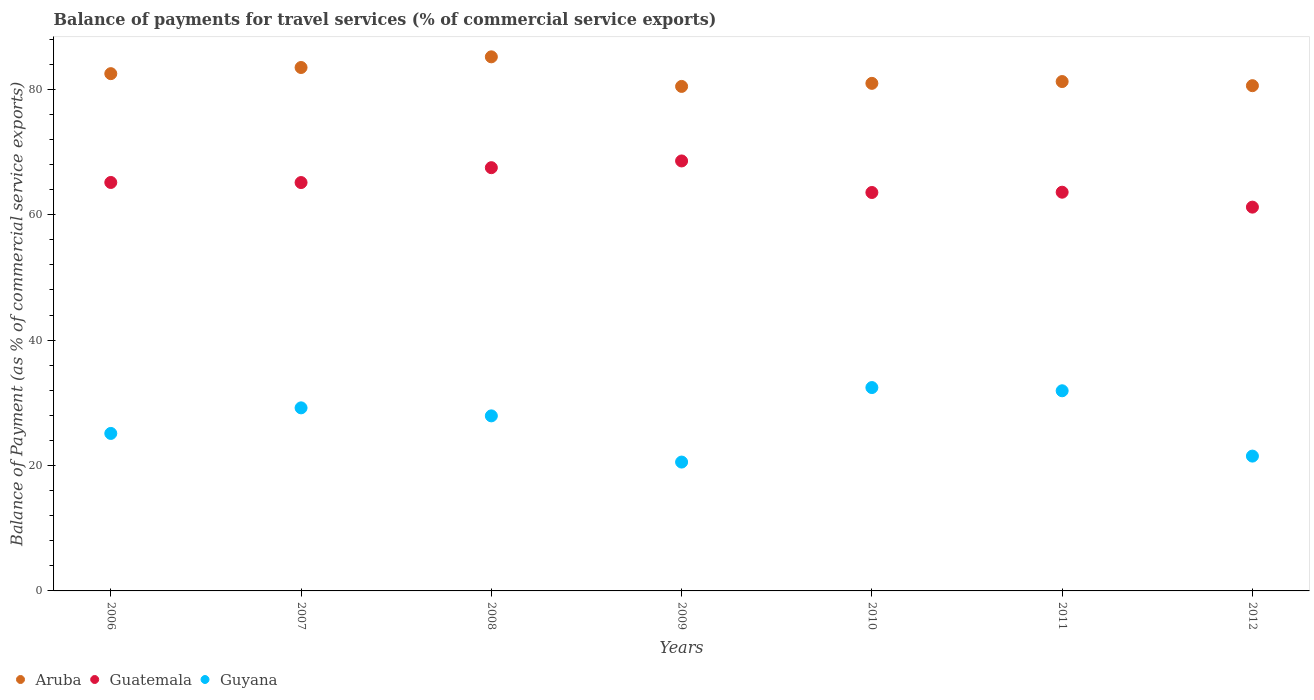Is the number of dotlines equal to the number of legend labels?
Provide a succinct answer. Yes. What is the balance of payments for travel services in Aruba in 2006?
Your answer should be very brief. 82.5. Across all years, what is the maximum balance of payments for travel services in Aruba?
Offer a very short reply. 85.18. Across all years, what is the minimum balance of payments for travel services in Aruba?
Ensure brevity in your answer.  80.47. What is the total balance of payments for travel services in Guatemala in the graph?
Your answer should be very brief. 454.72. What is the difference between the balance of payments for travel services in Guyana in 2006 and that in 2012?
Your response must be concise. 3.62. What is the difference between the balance of payments for travel services in Guatemala in 2011 and the balance of payments for travel services in Guyana in 2009?
Provide a succinct answer. 43.04. What is the average balance of payments for travel services in Aruba per year?
Your answer should be compact. 82.06. In the year 2008, what is the difference between the balance of payments for travel services in Guyana and balance of payments for travel services in Aruba?
Your answer should be very brief. -57.26. What is the ratio of the balance of payments for travel services in Guatemala in 2008 to that in 2010?
Your answer should be very brief. 1.06. Is the difference between the balance of payments for travel services in Guyana in 2007 and 2012 greater than the difference between the balance of payments for travel services in Aruba in 2007 and 2012?
Give a very brief answer. Yes. What is the difference between the highest and the second highest balance of payments for travel services in Guyana?
Make the answer very short. 0.51. What is the difference between the highest and the lowest balance of payments for travel services in Aruba?
Your answer should be very brief. 4.72. In how many years, is the balance of payments for travel services in Aruba greater than the average balance of payments for travel services in Aruba taken over all years?
Ensure brevity in your answer.  3. Is the sum of the balance of payments for travel services in Guatemala in 2010 and 2012 greater than the maximum balance of payments for travel services in Aruba across all years?
Your response must be concise. Yes. Is it the case that in every year, the sum of the balance of payments for travel services in Aruba and balance of payments for travel services in Guyana  is greater than the balance of payments for travel services in Guatemala?
Offer a very short reply. Yes. What is the difference between two consecutive major ticks on the Y-axis?
Your answer should be very brief. 20. Does the graph contain any zero values?
Keep it short and to the point. No. How many legend labels are there?
Your response must be concise. 3. How are the legend labels stacked?
Keep it short and to the point. Horizontal. What is the title of the graph?
Offer a very short reply. Balance of payments for travel services (% of commercial service exports). Does "Burkina Faso" appear as one of the legend labels in the graph?
Provide a short and direct response. No. What is the label or title of the Y-axis?
Offer a terse response. Balance of Payment (as % of commercial service exports). What is the Balance of Payment (as % of commercial service exports) of Aruba in 2006?
Offer a very short reply. 82.5. What is the Balance of Payment (as % of commercial service exports) of Guatemala in 2006?
Offer a terse response. 65.15. What is the Balance of Payment (as % of commercial service exports) in Guyana in 2006?
Your answer should be very brief. 25.12. What is the Balance of Payment (as % of commercial service exports) in Aruba in 2007?
Make the answer very short. 83.48. What is the Balance of Payment (as % of commercial service exports) in Guatemala in 2007?
Your response must be concise. 65.13. What is the Balance of Payment (as % of commercial service exports) in Guyana in 2007?
Offer a very short reply. 29.2. What is the Balance of Payment (as % of commercial service exports) of Aruba in 2008?
Ensure brevity in your answer.  85.18. What is the Balance of Payment (as % of commercial service exports) of Guatemala in 2008?
Your answer should be very brief. 67.51. What is the Balance of Payment (as % of commercial service exports) of Guyana in 2008?
Give a very brief answer. 27.92. What is the Balance of Payment (as % of commercial service exports) of Aruba in 2009?
Your answer should be compact. 80.47. What is the Balance of Payment (as % of commercial service exports) in Guatemala in 2009?
Provide a succinct answer. 68.58. What is the Balance of Payment (as % of commercial service exports) of Guyana in 2009?
Provide a succinct answer. 20.55. What is the Balance of Payment (as % of commercial service exports) of Aruba in 2010?
Offer a terse response. 80.95. What is the Balance of Payment (as % of commercial service exports) of Guatemala in 2010?
Provide a succinct answer. 63.55. What is the Balance of Payment (as % of commercial service exports) of Guyana in 2010?
Your answer should be very brief. 32.44. What is the Balance of Payment (as % of commercial service exports) of Aruba in 2011?
Your answer should be very brief. 81.24. What is the Balance of Payment (as % of commercial service exports) of Guatemala in 2011?
Provide a short and direct response. 63.59. What is the Balance of Payment (as % of commercial service exports) of Guyana in 2011?
Offer a terse response. 31.92. What is the Balance of Payment (as % of commercial service exports) of Aruba in 2012?
Keep it short and to the point. 80.58. What is the Balance of Payment (as % of commercial service exports) in Guatemala in 2012?
Provide a succinct answer. 61.21. What is the Balance of Payment (as % of commercial service exports) in Guyana in 2012?
Your answer should be very brief. 21.5. Across all years, what is the maximum Balance of Payment (as % of commercial service exports) of Aruba?
Offer a very short reply. 85.18. Across all years, what is the maximum Balance of Payment (as % of commercial service exports) of Guatemala?
Provide a succinct answer. 68.58. Across all years, what is the maximum Balance of Payment (as % of commercial service exports) of Guyana?
Your response must be concise. 32.44. Across all years, what is the minimum Balance of Payment (as % of commercial service exports) in Aruba?
Ensure brevity in your answer.  80.47. Across all years, what is the minimum Balance of Payment (as % of commercial service exports) in Guatemala?
Offer a terse response. 61.21. Across all years, what is the minimum Balance of Payment (as % of commercial service exports) of Guyana?
Offer a very short reply. 20.55. What is the total Balance of Payment (as % of commercial service exports) of Aruba in the graph?
Provide a short and direct response. 574.42. What is the total Balance of Payment (as % of commercial service exports) of Guatemala in the graph?
Provide a short and direct response. 454.72. What is the total Balance of Payment (as % of commercial service exports) of Guyana in the graph?
Give a very brief answer. 188.65. What is the difference between the Balance of Payment (as % of commercial service exports) of Aruba in 2006 and that in 2007?
Offer a very short reply. -0.98. What is the difference between the Balance of Payment (as % of commercial service exports) in Guatemala in 2006 and that in 2007?
Your answer should be compact. 0.01. What is the difference between the Balance of Payment (as % of commercial service exports) of Guyana in 2006 and that in 2007?
Your response must be concise. -4.08. What is the difference between the Balance of Payment (as % of commercial service exports) in Aruba in 2006 and that in 2008?
Your response must be concise. -2.68. What is the difference between the Balance of Payment (as % of commercial service exports) in Guatemala in 2006 and that in 2008?
Provide a short and direct response. -2.36. What is the difference between the Balance of Payment (as % of commercial service exports) in Guyana in 2006 and that in 2008?
Make the answer very short. -2.8. What is the difference between the Balance of Payment (as % of commercial service exports) of Aruba in 2006 and that in 2009?
Make the answer very short. 2.04. What is the difference between the Balance of Payment (as % of commercial service exports) of Guatemala in 2006 and that in 2009?
Your answer should be compact. -3.43. What is the difference between the Balance of Payment (as % of commercial service exports) of Guyana in 2006 and that in 2009?
Keep it short and to the point. 4.57. What is the difference between the Balance of Payment (as % of commercial service exports) in Aruba in 2006 and that in 2010?
Offer a terse response. 1.55. What is the difference between the Balance of Payment (as % of commercial service exports) in Guatemala in 2006 and that in 2010?
Give a very brief answer. 1.6. What is the difference between the Balance of Payment (as % of commercial service exports) in Guyana in 2006 and that in 2010?
Provide a succinct answer. -7.32. What is the difference between the Balance of Payment (as % of commercial service exports) in Aruba in 2006 and that in 2011?
Provide a succinct answer. 1.26. What is the difference between the Balance of Payment (as % of commercial service exports) in Guatemala in 2006 and that in 2011?
Provide a succinct answer. 1.55. What is the difference between the Balance of Payment (as % of commercial service exports) of Guyana in 2006 and that in 2011?
Provide a succinct answer. -6.8. What is the difference between the Balance of Payment (as % of commercial service exports) in Aruba in 2006 and that in 2012?
Offer a very short reply. 1.92. What is the difference between the Balance of Payment (as % of commercial service exports) of Guatemala in 2006 and that in 2012?
Give a very brief answer. 3.93. What is the difference between the Balance of Payment (as % of commercial service exports) in Guyana in 2006 and that in 2012?
Offer a terse response. 3.62. What is the difference between the Balance of Payment (as % of commercial service exports) in Aruba in 2007 and that in 2008?
Ensure brevity in your answer.  -1.7. What is the difference between the Balance of Payment (as % of commercial service exports) of Guatemala in 2007 and that in 2008?
Make the answer very short. -2.37. What is the difference between the Balance of Payment (as % of commercial service exports) of Guyana in 2007 and that in 2008?
Make the answer very short. 1.28. What is the difference between the Balance of Payment (as % of commercial service exports) in Aruba in 2007 and that in 2009?
Your answer should be compact. 3.02. What is the difference between the Balance of Payment (as % of commercial service exports) of Guatemala in 2007 and that in 2009?
Your answer should be very brief. -3.45. What is the difference between the Balance of Payment (as % of commercial service exports) in Guyana in 2007 and that in 2009?
Offer a very short reply. 8.65. What is the difference between the Balance of Payment (as % of commercial service exports) of Aruba in 2007 and that in 2010?
Give a very brief answer. 2.53. What is the difference between the Balance of Payment (as % of commercial service exports) of Guatemala in 2007 and that in 2010?
Your answer should be very brief. 1.59. What is the difference between the Balance of Payment (as % of commercial service exports) in Guyana in 2007 and that in 2010?
Offer a very short reply. -3.24. What is the difference between the Balance of Payment (as % of commercial service exports) in Aruba in 2007 and that in 2011?
Make the answer very short. 2.24. What is the difference between the Balance of Payment (as % of commercial service exports) of Guatemala in 2007 and that in 2011?
Make the answer very short. 1.54. What is the difference between the Balance of Payment (as % of commercial service exports) of Guyana in 2007 and that in 2011?
Offer a terse response. -2.72. What is the difference between the Balance of Payment (as % of commercial service exports) in Aruba in 2007 and that in 2012?
Provide a succinct answer. 2.9. What is the difference between the Balance of Payment (as % of commercial service exports) of Guatemala in 2007 and that in 2012?
Provide a succinct answer. 3.92. What is the difference between the Balance of Payment (as % of commercial service exports) in Guyana in 2007 and that in 2012?
Provide a short and direct response. 7.7. What is the difference between the Balance of Payment (as % of commercial service exports) of Aruba in 2008 and that in 2009?
Offer a very short reply. 4.72. What is the difference between the Balance of Payment (as % of commercial service exports) in Guatemala in 2008 and that in 2009?
Make the answer very short. -1.07. What is the difference between the Balance of Payment (as % of commercial service exports) in Guyana in 2008 and that in 2009?
Make the answer very short. 7.37. What is the difference between the Balance of Payment (as % of commercial service exports) in Aruba in 2008 and that in 2010?
Your answer should be very brief. 4.23. What is the difference between the Balance of Payment (as % of commercial service exports) of Guatemala in 2008 and that in 2010?
Provide a short and direct response. 3.96. What is the difference between the Balance of Payment (as % of commercial service exports) of Guyana in 2008 and that in 2010?
Your answer should be compact. -4.52. What is the difference between the Balance of Payment (as % of commercial service exports) of Aruba in 2008 and that in 2011?
Ensure brevity in your answer.  3.94. What is the difference between the Balance of Payment (as % of commercial service exports) of Guatemala in 2008 and that in 2011?
Offer a terse response. 3.91. What is the difference between the Balance of Payment (as % of commercial service exports) in Guyana in 2008 and that in 2011?
Provide a succinct answer. -4. What is the difference between the Balance of Payment (as % of commercial service exports) of Aruba in 2008 and that in 2012?
Keep it short and to the point. 4.6. What is the difference between the Balance of Payment (as % of commercial service exports) in Guatemala in 2008 and that in 2012?
Offer a terse response. 6.29. What is the difference between the Balance of Payment (as % of commercial service exports) of Guyana in 2008 and that in 2012?
Offer a very short reply. 6.42. What is the difference between the Balance of Payment (as % of commercial service exports) in Aruba in 2009 and that in 2010?
Keep it short and to the point. -0.49. What is the difference between the Balance of Payment (as % of commercial service exports) of Guatemala in 2009 and that in 2010?
Offer a terse response. 5.03. What is the difference between the Balance of Payment (as % of commercial service exports) in Guyana in 2009 and that in 2010?
Keep it short and to the point. -11.88. What is the difference between the Balance of Payment (as % of commercial service exports) of Aruba in 2009 and that in 2011?
Make the answer very short. -0.78. What is the difference between the Balance of Payment (as % of commercial service exports) of Guatemala in 2009 and that in 2011?
Your answer should be very brief. 4.99. What is the difference between the Balance of Payment (as % of commercial service exports) of Guyana in 2009 and that in 2011?
Ensure brevity in your answer.  -11.37. What is the difference between the Balance of Payment (as % of commercial service exports) of Aruba in 2009 and that in 2012?
Your answer should be very brief. -0.12. What is the difference between the Balance of Payment (as % of commercial service exports) in Guatemala in 2009 and that in 2012?
Provide a succinct answer. 7.37. What is the difference between the Balance of Payment (as % of commercial service exports) in Guyana in 2009 and that in 2012?
Your answer should be very brief. -0.95. What is the difference between the Balance of Payment (as % of commercial service exports) in Aruba in 2010 and that in 2011?
Ensure brevity in your answer.  -0.29. What is the difference between the Balance of Payment (as % of commercial service exports) of Guatemala in 2010 and that in 2011?
Provide a short and direct response. -0.05. What is the difference between the Balance of Payment (as % of commercial service exports) in Guyana in 2010 and that in 2011?
Offer a terse response. 0.51. What is the difference between the Balance of Payment (as % of commercial service exports) of Aruba in 2010 and that in 2012?
Make the answer very short. 0.37. What is the difference between the Balance of Payment (as % of commercial service exports) in Guatemala in 2010 and that in 2012?
Provide a succinct answer. 2.33. What is the difference between the Balance of Payment (as % of commercial service exports) of Guyana in 2010 and that in 2012?
Provide a succinct answer. 10.93. What is the difference between the Balance of Payment (as % of commercial service exports) in Aruba in 2011 and that in 2012?
Your answer should be very brief. 0.66. What is the difference between the Balance of Payment (as % of commercial service exports) of Guatemala in 2011 and that in 2012?
Keep it short and to the point. 2.38. What is the difference between the Balance of Payment (as % of commercial service exports) of Guyana in 2011 and that in 2012?
Give a very brief answer. 10.42. What is the difference between the Balance of Payment (as % of commercial service exports) in Aruba in 2006 and the Balance of Payment (as % of commercial service exports) in Guatemala in 2007?
Offer a terse response. 17.37. What is the difference between the Balance of Payment (as % of commercial service exports) in Aruba in 2006 and the Balance of Payment (as % of commercial service exports) in Guyana in 2007?
Keep it short and to the point. 53.3. What is the difference between the Balance of Payment (as % of commercial service exports) of Guatemala in 2006 and the Balance of Payment (as % of commercial service exports) of Guyana in 2007?
Provide a succinct answer. 35.95. What is the difference between the Balance of Payment (as % of commercial service exports) of Aruba in 2006 and the Balance of Payment (as % of commercial service exports) of Guatemala in 2008?
Your answer should be compact. 15. What is the difference between the Balance of Payment (as % of commercial service exports) of Aruba in 2006 and the Balance of Payment (as % of commercial service exports) of Guyana in 2008?
Ensure brevity in your answer.  54.58. What is the difference between the Balance of Payment (as % of commercial service exports) of Guatemala in 2006 and the Balance of Payment (as % of commercial service exports) of Guyana in 2008?
Keep it short and to the point. 37.23. What is the difference between the Balance of Payment (as % of commercial service exports) of Aruba in 2006 and the Balance of Payment (as % of commercial service exports) of Guatemala in 2009?
Keep it short and to the point. 13.92. What is the difference between the Balance of Payment (as % of commercial service exports) in Aruba in 2006 and the Balance of Payment (as % of commercial service exports) in Guyana in 2009?
Your response must be concise. 61.95. What is the difference between the Balance of Payment (as % of commercial service exports) in Guatemala in 2006 and the Balance of Payment (as % of commercial service exports) in Guyana in 2009?
Provide a succinct answer. 44.6. What is the difference between the Balance of Payment (as % of commercial service exports) in Aruba in 2006 and the Balance of Payment (as % of commercial service exports) in Guatemala in 2010?
Ensure brevity in your answer.  18.95. What is the difference between the Balance of Payment (as % of commercial service exports) of Aruba in 2006 and the Balance of Payment (as % of commercial service exports) of Guyana in 2010?
Your answer should be very brief. 50.07. What is the difference between the Balance of Payment (as % of commercial service exports) in Guatemala in 2006 and the Balance of Payment (as % of commercial service exports) in Guyana in 2010?
Offer a very short reply. 32.71. What is the difference between the Balance of Payment (as % of commercial service exports) in Aruba in 2006 and the Balance of Payment (as % of commercial service exports) in Guatemala in 2011?
Your answer should be very brief. 18.91. What is the difference between the Balance of Payment (as % of commercial service exports) of Aruba in 2006 and the Balance of Payment (as % of commercial service exports) of Guyana in 2011?
Offer a terse response. 50.58. What is the difference between the Balance of Payment (as % of commercial service exports) in Guatemala in 2006 and the Balance of Payment (as % of commercial service exports) in Guyana in 2011?
Offer a terse response. 33.22. What is the difference between the Balance of Payment (as % of commercial service exports) in Aruba in 2006 and the Balance of Payment (as % of commercial service exports) in Guatemala in 2012?
Give a very brief answer. 21.29. What is the difference between the Balance of Payment (as % of commercial service exports) of Aruba in 2006 and the Balance of Payment (as % of commercial service exports) of Guyana in 2012?
Your answer should be very brief. 61. What is the difference between the Balance of Payment (as % of commercial service exports) in Guatemala in 2006 and the Balance of Payment (as % of commercial service exports) in Guyana in 2012?
Make the answer very short. 43.64. What is the difference between the Balance of Payment (as % of commercial service exports) in Aruba in 2007 and the Balance of Payment (as % of commercial service exports) in Guatemala in 2008?
Keep it short and to the point. 15.98. What is the difference between the Balance of Payment (as % of commercial service exports) of Aruba in 2007 and the Balance of Payment (as % of commercial service exports) of Guyana in 2008?
Give a very brief answer. 55.56. What is the difference between the Balance of Payment (as % of commercial service exports) of Guatemala in 2007 and the Balance of Payment (as % of commercial service exports) of Guyana in 2008?
Provide a short and direct response. 37.21. What is the difference between the Balance of Payment (as % of commercial service exports) of Aruba in 2007 and the Balance of Payment (as % of commercial service exports) of Guatemala in 2009?
Provide a short and direct response. 14.9. What is the difference between the Balance of Payment (as % of commercial service exports) of Aruba in 2007 and the Balance of Payment (as % of commercial service exports) of Guyana in 2009?
Offer a very short reply. 62.93. What is the difference between the Balance of Payment (as % of commercial service exports) in Guatemala in 2007 and the Balance of Payment (as % of commercial service exports) in Guyana in 2009?
Offer a very short reply. 44.58. What is the difference between the Balance of Payment (as % of commercial service exports) in Aruba in 2007 and the Balance of Payment (as % of commercial service exports) in Guatemala in 2010?
Your answer should be compact. 19.94. What is the difference between the Balance of Payment (as % of commercial service exports) of Aruba in 2007 and the Balance of Payment (as % of commercial service exports) of Guyana in 2010?
Your answer should be very brief. 51.05. What is the difference between the Balance of Payment (as % of commercial service exports) of Guatemala in 2007 and the Balance of Payment (as % of commercial service exports) of Guyana in 2010?
Provide a short and direct response. 32.7. What is the difference between the Balance of Payment (as % of commercial service exports) of Aruba in 2007 and the Balance of Payment (as % of commercial service exports) of Guatemala in 2011?
Keep it short and to the point. 19.89. What is the difference between the Balance of Payment (as % of commercial service exports) in Aruba in 2007 and the Balance of Payment (as % of commercial service exports) in Guyana in 2011?
Provide a short and direct response. 51.56. What is the difference between the Balance of Payment (as % of commercial service exports) of Guatemala in 2007 and the Balance of Payment (as % of commercial service exports) of Guyana in 2011?
Your response must be concise. 33.21. What is the difference between the Balance of Payment (as % of commercial service exports) in Aruba in 2007 and the Balance of Payment (as % of commercial service exports) in Guatemala in 2012?
Your answer should be very brief. 22.27. What is the difference between the Balance of Payment (as % of commercial service exports) in Aruba in 2007 and the Balance of Payment (as % of commercial service exports) in Guyana in 2012?
Keep it short and to the point. 61.98. What is the difference between the Balance of Payment (as % of commercial service exports) in Guatemala in 2007 and the Balance of Payment (as % of commercial service exports) in Guyana in 2012?
Make the answer very short. 43.63. What is the difference between the Balance of Payment (as % of commercial service exports) of Aruba in 2008 and the Balance of Payment (as % of commercial service exports) of Guatemala in 2009?
Offer a very short reply. 16.6. What is the difference between the Balance of Payment (as % of commercial service exports) in Aruba in 2008 and the Balance of Payment (as % of commercial service exports) in Guyana in 2009?
Make the answer very short. 64.63. What is the difference between the Balance of Payment (as % of commercial service exports) of Guatemala in 2008 and the Balance of Payment (as % of commercial service exports) of Guyana in 2009?
Offer a terse response. 46.95. What is the difference between the Balance of Payment (as % of commercial service exports) of Aruba in 2008 and the Balance of Payment (as % of commercial service exports) of Guatemala in 2010?
Offer a very short reply. 21.64. What is the difference between the Balance of Payment (as % of commercial service exports) in Aruba in 2008 and the Balance of Payment (as % of commercial service exports) in Guyana in 2010?
Your answer should be very brief. 52.75. What is the difference between the Balance of Payment (as % of commercial service exports) of Guatemala in 2008 and the Balance of Payment (as % of commercial service exports) of Guyana in 2010?
Your response must be concise. 35.07. What is the difference between the Balance of Payment (as % of commercial service exports) in Aruba in 2008 and the Balance of Payment (as % of commercial service exports) in Guatemala in 2011?
Your answer should be compact. 21.59. What is the difference between the Balance of Payment (as % of commercial service exports) of Aruba in 2008 and the Balance of Payment (as % of commercial service exports) of Guyana in 2011?
Provide a succinct answer. 53.26. What is the difference between the Balance of Payment (as % of commercial service exports) in Guatemala in 2008 and the Balance of Payment (as % of commercial service exports) in Guyana in 2011?
Make the answer very short. 35.58. What is the difference between the Balance of Payment (as % of commercial service exports) in Aruba in 2008 and the Balance of Payment (as % of commercial service exports) in Guatemala in 2012?
Provide a succinct answer. 23.97. What is the difference between the Balance of Payment (as % of commercial service exports) in Aruba in 2008 and the Balance of Payment (as % of commercial service exports) in Guyana in 2012?
Offer a terse response. 63.68. What is the difference between the Balance of Payment (as % of commercial service exports) of Guatemala in 2008 and the Balance of Payment (as % of commercial service exports) of Guyana in 2012?
Ensure brevity in your answer.  46. What is the difference between the Balance of Payment (as % of commercial service exports) in Aruba in 2009 and the Balance of Payment (as % of commercial service exports) in Guatemala in 2010?
Ensure brevity in your answer.  16.92. What is the difference between the Balance of Payment (as % of commercial service exports) in Aruba in 2009 and the Balance of Payment (as % of commercial service exports) in Guyana in 2010?
Your response must be concise. 48.03. What is the difference between the Balance of Payment (as % of commercial service exports) of Guatemala in 2009 and the Balance of Payment (as % of commercial service exports) of Guyana in 2010?
Offer a very short reply. 36.14. What is the difference between the Balance of Payment (as % of commercial service exports) in Aruba in 2009 and the Balance of Payment (as % of commercial service exports) in Guatemala in 2011?
Keep it short and to the point. 16.87. What is the difference between the Balance of Payment (as % of commercial service exports) in Aruba in 2009 and the Balance of Payment (as % of commercial service exports) in Guyana in 2011?
Keep it short and to the point. 48.54. What is the difference between the Balance of Payment (as % of commercial service exports) in Guatemala in 2009 and the Balance of Payment (as % of commercial service exports) in Guyana in 2011?
Your answer should be compact. 36.66. What is the difference between the Balance of Payment (as % of commercial service exports) of Aruba in 2009 and the Balance of Payment (as % of commercial service exports) of Guatemala in 2012?
Give a very brief answer. 19.25. What is the difference between the Balance of Payment (as % of commercial service exports) of Aruba in 2009 and the Balance of Payment (as % of commercial service exports) of Guyana in 2012?
Provide a succinct answer. 58.96. What is the difference between the Balance of Payment (as % of commercial service exports) in Guatemala in 2009 and the Balance of Payment (as % of commercial service exports) in Guyana in 2012?
Give a very brief answer. 47.08. What is the difference between the Balance of Payment (as % of commercial service exports) of Aruba in 2010 and the Balance of Payment (as % of commercial service exports) of Guatemala in 2011?
Keep it short and to the point. 17.36. What is the difference between the Balance of Payment (as % of commercial service exports) of Aruba in 2010 and the Balance of Payment (as % of commercial service exports) of Guyana in 2011?
Give a very brief answer. 49.03. What is the difference between the Balance of Payment (as % of commercial service exports) in Guatemala in 2010 and the Balance of Payment (as % of commercial service exports) in Guyana in 2011?
Keep it short and to the point. 31.63. What is the difference between the Balance of Payment (as % of commercial service exports) of Aruba in 2010 and the Balance of Payment (as % of commercial service exports) of Guatemala in 2012?
Make the answer very short. 19.74. What is the difference between the Balance of Payment (as % of commercial service exports) in Aruba in 2010 and the Balance of Payment (as % of commercial service exports) in Guyana in 2012?
Give a very brief answer. 59.45. What is the difference between the Balance of Payment (as % of commercial service exports) in Guatemala in 2010 and the Balance of Payment (as % of commercial service exports) in Guyana in 2012?
Your answer should be compact. 42.04. What is the difference between the Balance of Payment (as % of commercial service exports) in Aruba in 2011 and the Balance of Payment (as % of commercial service exports) in Guatemala in 2012?
Your answer should be very brief. 20.03. What is the difference between the Balance of Payment (as % of commercial service exports) in Aruba in 2011 and the Balance of Payment (as % of commercial service exports) in Guyana in 2012?
Your answer should be compact. 59.74. What is the difference between the Balance of Payment (as % of commercial service exports) in Guatemala in 2011 and the Balance of Payment (as % of commercial service exports) in Guyana in 2012?
Provide a short and direct response. 42.09. What is the average Balance of Payment (as % of commercial service exports) in Aruba per year?
Give a very brief answer. 82.06. What is the average Balance of Payment (as % of commercial service exports) of Guatemala per year?
Keep it short and to the point. 64.96. What is the average Balance of Payment (as % of commercial service exports) in Guyana per year?
Give a very brief answer. 26.95. In the year 2006, what is the difference between the Balance of Payment (as % of commercial service exports) of Aruba and Balance of Payment (as % of commercial service exports) of Guatemala?
Your response must be concise. 17.36. In the year 2006, what is the difference between the Balance of Payment (as % of commercial service exports) in Aruba and Balance of Payment (as % of commercial service exports) in Guyana?
Ensure brevity in your answer.  57.38. In the year 2006, what is the difference between the Balance of Payment (as % of commercial service exports) of Guatemala and Balance of Payment (as % of commercial service exports) of Guyana?
Your answer should be very brief. 40.03. In the year 2007, what is the difference between the Balance of Payment (as % of commercial service exports) of Aruba and Balance of Payment (as % of commercial service exports) of Guatemala?
Your response must be concise. 18.35. In the year 2007, what is the difference between the Balance of Payment (as % of commercial service exports) of Aruba and Balance of Payment (as % of commercial service exports) of Guyana?
Provide a short and direct response. 54.28. In the year 2007, what is the difference between the Balance of Payment (as % of commercial service exports) in Guatemala and Balance of Payment (as % of commercial service exports) in Guyana?
Give a very brief answer. 35.93. In the year 2008, what is the difference between the Balance of Payment (as % of commercial service exports) in Aruba and Balance of Payment (as % of commercial service exports) in Guatemala?
Your answer should be very brief. 17.68. In the year 2008, what is the difference between the Balance of Payment (as % of commercial service exports) of Aruba and Balance of Payment (as % of commercial service exports) of Guyana?
Keep it short and to the point. 57.26. In the year 2008, what is the difference between the Balance of Payment (as % of commercial service exports) of Guatemala and Balance of Payment (as % of commercial service exports) of Guyana?
Offer a very short reply. 39.59. In the year 2009, what is the difference between the Balance of Payment (as % of commercial service exports) in Aruba and Balance of Payment (as % of commercial service exports) in Guatemala?
Offer a terse response. 11.89. In the year 2009, what is the difference between the Balance of Payment (as % of commercial service exports) of Aruba and Balance of Payment (as % of commercial service exports) of Guyana?
Your answer should be compact. 59.91. In the year 2009, what is the difference between the Balance of Payment (as % of commercial service exports) in Guatemala and Balance of Payment (as % of commercial service exports) in Guyana?
Make the answer very short. 48.03. In the year 2010, what is the difference between the Balance of Payment (as % of commercial service exports) of Aruba and Balance of Payment (as % of commercial service exports) of Guatemala?
Make the answer very short. 17.41. In the year 2010, what is the difference between the Balance of Payment (as % of commercial service exports) in Aruba and Balance of Payment (as % of commercial service exports) in Guyana?
Make the answer very short. 48.52. In the year 2010, what is the difference between the Balance of Payment (as % of commercial service exports) of Guatemala and Balance of Payment (as % of commercial service exports) of Guyana?
Ensure brevity in your answer.  31.11. In the year 2011, what is the difference between the Balance of Payment (as % of commercial service exports) in Aruba and Balance of Payment (as % of commercial service exports) in Guatemala?
Offer a very short reply. 17.65. In the year 2011, what is the difference between the Balance of Payment (as % of commercial service exports) of Aruba and Balance of Payment (as % of commercial service exports) of Guyana?
Keep it short and to the point. 49.32. In the year 2011, what is the difference between the Balance of Payment (as % of commercial service exports) in Guatemala and Balance of Payment (as % of commercial service exports) in Guyana?
Keep it short and to the point. 31.67. In the year 2012, what is the difference between the Balance of Payment (as % of commercial service exports) of Aruba and Balance of Payment (as % of commercial service exports) of Guatemala?
Give a very brief answer. 19.37. In the year 2012, what is the difference between the Balance of Payment (as % of commercial service exports) in Aruba and Balance of Payment (as % of commercial service exports) in Guyana?
Your answer should be compact. 59.08. In the year 2012, what is the difference between the Balance of Payment (as % of commercial service exports) of Guatemala and Balance of Payment (as % of commercial service exports) of Guyana?
Ensure brevity in your answer.  39.71. What is the ratio of the Balance of Payment (as % of commercial service exports) in Guatemala in 2006 to that in 2007?
Offer a very short reply. 1. What is the ratio of the Balance of Payment (as % of commercial service exports) of Guyana in 2006 to that in 2007?
Give a very brief answer. 0.86. What is the ratio of the Balance of Payment (as % of commercial service exports) of Aruba in 2006 to that in 2008?
Ensure brevity in your answer.  0.97. What is the ratio of the Balance of Payment (as % of commercial service exports) in Guatemala in 2006 to that in 2008?
Ensure brevity in your answer.  0.97. What is the ratio of the Balance of Payment (as % of commercial service exports) in Guyana in 2006 to that in 2008?
Ensure brevity in your answer.  0.9. What is the ratio of the Balance of Payment (as % of commercial service exports) of Aruba in 2006 to that in 2009?
Give a very brief answer. 1.03. What is the ratio of the Balance of Payment (as % of commercial service exports) in Guatemala in 2006 to that in 2009?
Give a very brief answer. 0.95. What is the ratio of the Balance of Payment (as % of commercial service exports) of Guyana in 2006 to that in 2009?
Make the answer very short. 1.22. What is the ratio of the Balance of Payment (as % of commercial service exports) of Aruba in 2006 to that in 2010?
Your answer should be very brief. 1.02. What is the ratio of the Balance of Payment (as % of commercial service exports) in Guatemala in 2006 to that in 2010?
Your answer should be very brief. 1.03. What is the ratio of the Balance of Payment (as % of commercial service exports) in Guyana in 2006 to that in 2010?
Offer a terse response. 0.77. What is the ratio of the Balance of Payment (as % of commercial service exports) in Aruba in 2006 to that in 2011?
Your answer should be compact. 1.02. What is the ratio of the Balance of Payment (as % of commercial service exports) in Guatemala in 2006 to that in 2011?
Offer a terse response. 1.02. What is the ratio of the Balance of Payment (as % of commercial service exports) in Guyana in 2006 to that in 2011?
Your response must be concise. 0.79. What is the ratio of the Balance of Payment (as % of commercial service exports) of Aruba in 2006 to that in 2012?
Your answer should be compact. 1.02. What is the ratio of the Balance of Payment (as % of commercial service exports) in Guatemala in 2006 to that in 2012?
Make the answer very short. 1.06. What is the ratio of the Balance of Payment (as % of commercial service exports) of Guyana in 2006 to that in 2012?
Offer a terse response. 1.17. What is the ratio of the Balance of Payment (as % of commercial service exports) in Guatemala in 2007 to that in 2008?
Your answer should be compact. 0.96. What is the ratio of the Balance of Payment (as % of commercial service exports) of Guyana in 2007 to that in 2008?
Your answer should be compact. 1.05. What is the ratio of the Balance of Payment (as % of commercial service exports) of Aruba in 2007 to that in 2009?
Ensure brevity in your answer.  1.04. What is the ratio of the Balance of Payment (as % of commercial service exports) of Guatemala in 2007 to that in 2009?
Provide a short and direct response. 0.95. What is the ratio of the Balance of Payment (as % of commercial service exports) in Guyana in 2007 to that in 2009?
Make the answer very short. 1.42. What is the ratio of the Balance of Payment (as % of commercial service exports) in Aruba in 2007 to that in 2010?
Offer a terse response. 1.03. What is the ratio of the Balance of Payment (as % of commercial service exports) in Guyana in 2007 to that in 2010?
Make the answer very short. 0.9. What is the ratio of the Balance of Payment (as % of commercial service exports) of Aruba in 2007 to that in 2011?
Offer a very short reply. 1.03. What is the ratio of the Balance of Payment (as % of commercial service exports) in Guatemala in 2007 to that in 2011?
Provide a succinct answer. 1.02. What is the ratio of the Balance of Payment (as % of commercial service exports) in Guyana in 2007 to that in 2011?
Offer a very short reply. 0.91. What is the ratio of the Balance of Payment (as % of commercial service exports) in Aruba in 2007 to that in 2012?
Your response must be concise. 1.04. What is the ratio of the Balance of Payment (as % of commercial service exports) in Guatemala in 2007 to that in 2012?
Provide a succinct answer. 1.06. What is the ratio of the Balance of Payment (as % of commercial service exports) of Guyana in 2007 to that in 2012?
Your answer should be compact. 1.36. What is the ratio of the Balance of Payment (as % of commercial service exports) in Aruba in 2008 to that in 2009?
Provide a short and direct response. 1.06. What is the ratio of the Balance of Payment (as % of commercial service exports) of Guatemala in 2008 to that in 2009?
Your answer should be compact. 0.98. What is the ratio of the Balance of Payment (as % of commercial service exports) in Guyana in 2008 to that in 2009?
Ensure brevity in your answer.  1.36. What is the ratio of the Balance of Payment (as % of commercial service exports) of Aruba in 2008 to that in 2010?
Your answer should be very brief. 1.05. What is the ratio of the Balance of Payment (as % of commercial service exports) of Guatemala in 2008 to that in 2010?
Your response must be concise. 1.06. What is the ratio of the Balance of Payment (as % of commercial service exports) of Guyana in 2008 to that in 2010?
Keep it short and to the point. 0.86. What is the ratio of the Balance of Payment (as % of commercial service exports) in Aruba in 2008 to that in 2011?
Offer a very short reply. 1.05. What is the ratio of the Balance of Payment (as % of commercial service exports) of Guatemala in 2008 to that in 2011?
Offer a very short reply. 1.06. What is the ratio of the Balance of Payment (as % of commercial service exports) in Guyana in 2008 to that in 2011?
Keep it short and to the point. 0.87. What is the ratio of the Balance of Payment (as % of commercial service exports) in Aruba in 2008 to that in 2012?
Ensure brevity in your answer.  1.06. What is the ratio of the Balance of Payment (as % of commercial service exports) of Guatemala in 2008 to that in 2012?
Make the answer very short. 1.1. What is the ratio of the Balance of Payment (as % of commercial service exports) in Guyana in 2008 to that in 2012?
Offer a very short reply. 1.3. What is the ratio of the Balance of Payment (as % of commercial service exports) of Guatemala in 2009 to that in 2010?
Ensure brevity in your answer.  1.08. What is the ratio of the Balance of Payment (as % of commercial service exports) of Guyana in 2009 to that in 2010?
Provide a short and direct response. 0.63. What is the ratio of the Balance of Payment (as % of commercial service exports) in Guatemala in 2009 to that in 2011?
Provide a succinct answer. 1.08. What is the ratio of the Balance of Payment (as % of commercial service exports) of Guyana in 2009 to that in 2011?
Your response must be concise. 0.64. What is the ratio of the Balance of Payment (as % of commercial service exports) in Aruba in 2009 to that in 2012?
Ensure brevity in your answer.  1. What is the ratio of the Balance of Payment (as % of commercial service exports) of Guatemala in 2009 to that in 2012?
Your answer should be very brief. 1.12. What is the ratio of the Balance of Payment (as % of commercial service exports) in Guyana in 2009 to that in 2012?
Give a very brief answer. 0.96. What is the ratio of the Balance of Payment (as % of commercial service exports) of Aruba in 2010 to that in 2011?
Give a very brief answer. 1. What is the ratio of the Balance of Payment (as % of commercial service exports) of Guyana in 2010 to that in 2011?
Give a very brief answer. 1.02. What is the ratio of the Balance of Payment (as % of commercial service exports) of Aruba in 2010 to that in 2012?
Offer a very short reply. 1. What is the ratio of the Balance of Payment (as % of commercial service exports) of Guatemala in 2010 to that in 2012?
Offer a terse response. 1.04. What is the ratio of the Balance of Payment (as % of commercial service exports) of Guyana in 2010 to that in 2012?
Your answer should be very brief. 1.51. What is the ratio of the Balance of Payment (as % of commercial service exports) in Aruba in 2011 to that in 2012?
Provide a short and direct response. 1.01. What is the ratio of the Balance of Payment (as % of commercial service exports) of Guatemala in 2011 to that in 2012?
Your response must be concise. 1.04. What is the ratio of the Balance of Payment (as % of commercial service exports) in Guyana in 2011 to that in 2012?
Offer a terse response. 1.48. What is the difference between the highest and the second highest Balance of Payment (as % of commercial service exports) in Aruba?
Make the answer very short. 1.7. What is the difference between the highest and the second highest Balance of Payment (as % of commercial service exports) of Guatemala?
Offer a terse response. 1.07. What is the difference between the highest and the second highest Balance of Payment (as % of commercial service exports) of Guyana?
Your answer should be very brief. 0.51. What is the difference between the highest and the lowest Balance of Payment (as % of commercial service exports) in Aruba?
Give a very brief answer. 4.72. What is the difference between the highest and the lowest Balance of Payment (as % of commercial service exports) in Guatemala?
Offer a terse response. 7.37. What is the difference between the highest and the lowest Balance of Payment (as % of commercial service exports) of Guyana?
Make the answer very short. 11.88. 